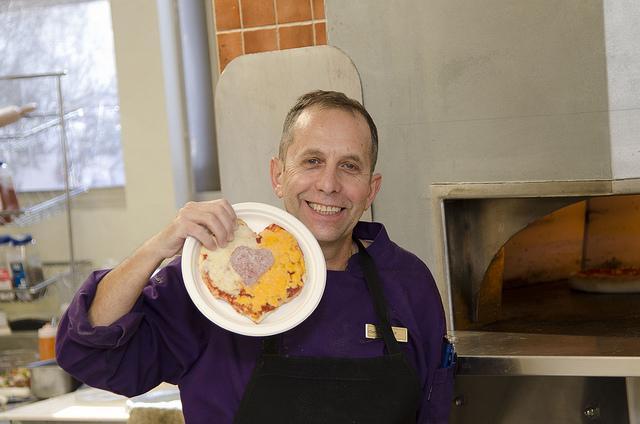How many zebras are shown in this picture?
Give a very brief answer. 0. 